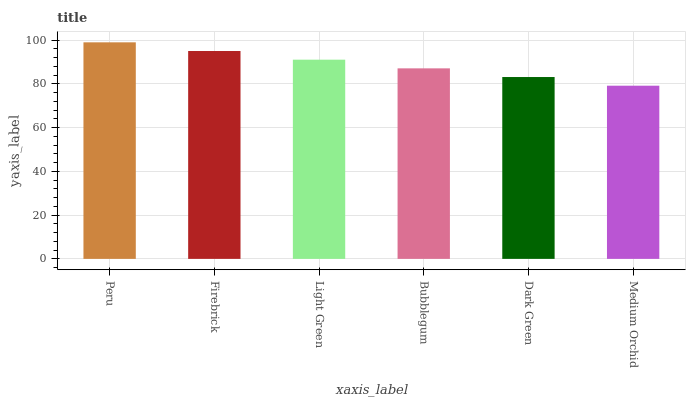Is Medium Orchid the minimum?
Answer yes or no. Yes. Is Peru the maximum?
Answer yes or no. Yes. Is Firebrick the minimum?
Answer yes or no. No. Is Firebrick the maximum?
Answer yes or no. No. Is Peru greater than Firebrick?
Answer yes or no. Yes. Is Firebrick less than Peru?
Answer yes or no. Yes. Is Firebrick greater than Peru?
Answer yes or no. No. Is Peru less than Firebrick?
Answer yes or no. No. Is Light Green the high median?
Answer yes or no. Yes. Is Bubblegum the low median?
Answer yes or no. Yes. Is Firebrick the high median?
Answer yes or no. No. Is Dark Green the low median?
Answer yes or no. No. 